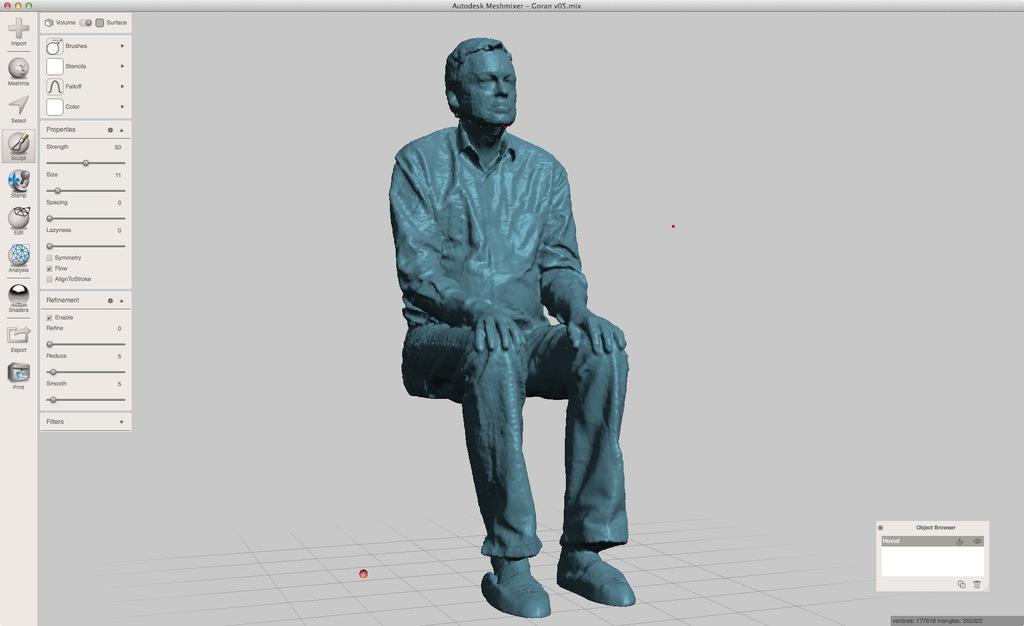How would you summarize this image in a sentence or two? In this image we can see a computer screen and a picture on it. 